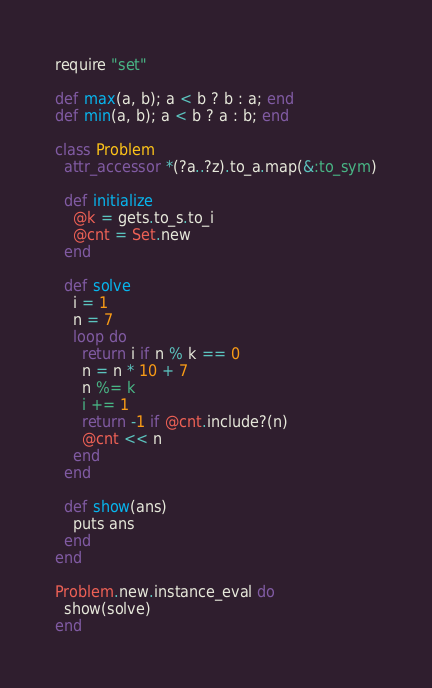<code> <loc_0><loc_0><loc_500><loc_500><_Ruby_>require "set"

def max(a, b); a < b ? b : a; end
def min(a, b); a < b ? a : b; end

class Problem
  attr_accessor *(?a..?z).to_a.map(&:to_sym)

  def initialize
    @k = gets.to_s.to_i
    @cnt = Set.new
  end

  def solve
    i = 1
    n = 7
    loop do
      return i if n % k == 0
      n = n * 10 + 7
      n %= k
      i += 1
      return -1 if @cnt.include?(n)
      @cnt << n
    end
  end

  def show(ans)
    puts ans
  end
end

Problem.new.instance_eval do
  show(solve)
end
</code> 